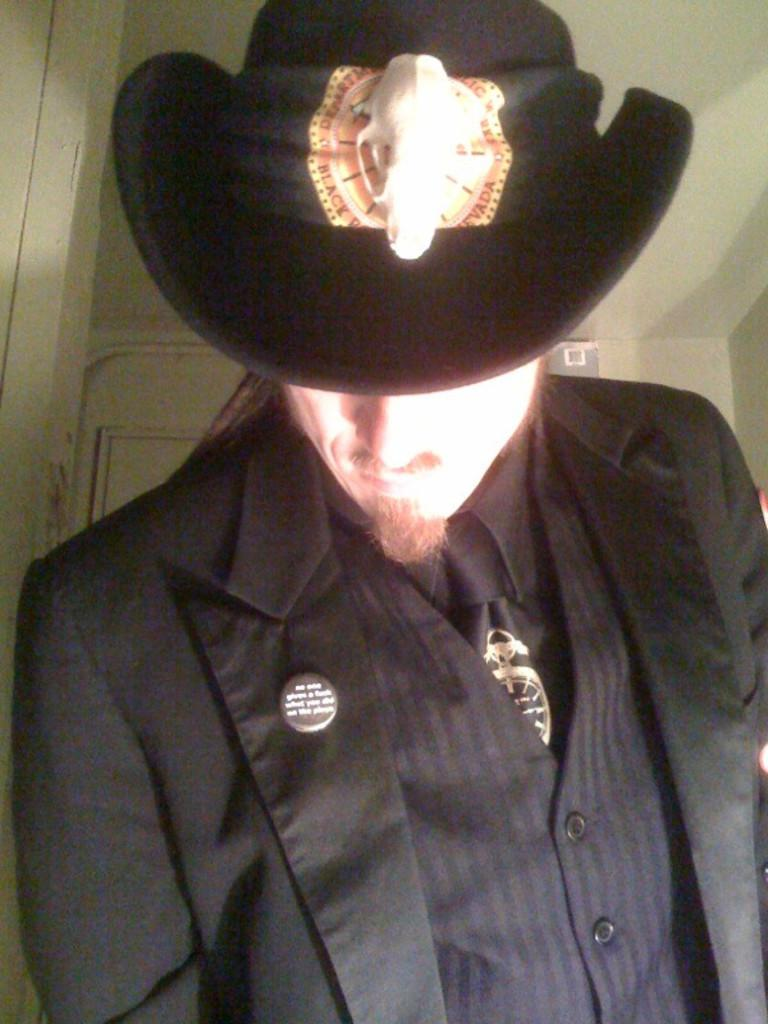What is the main subject of the image? There is a man in the image. What is the man wearing? The man is wearing a black shirt, a black blazer, and a black hat. What can be seen in the background of the image? There is a white wall and a white door in the background of the image. Where was the image taken? The image was taken inside a room. What type of authority does the man hold in the image? There is no indication of the man's authority or position in the image. What record is the man attempting to break in the image? There is no record-breaking activity or any indication of a record in the image. 